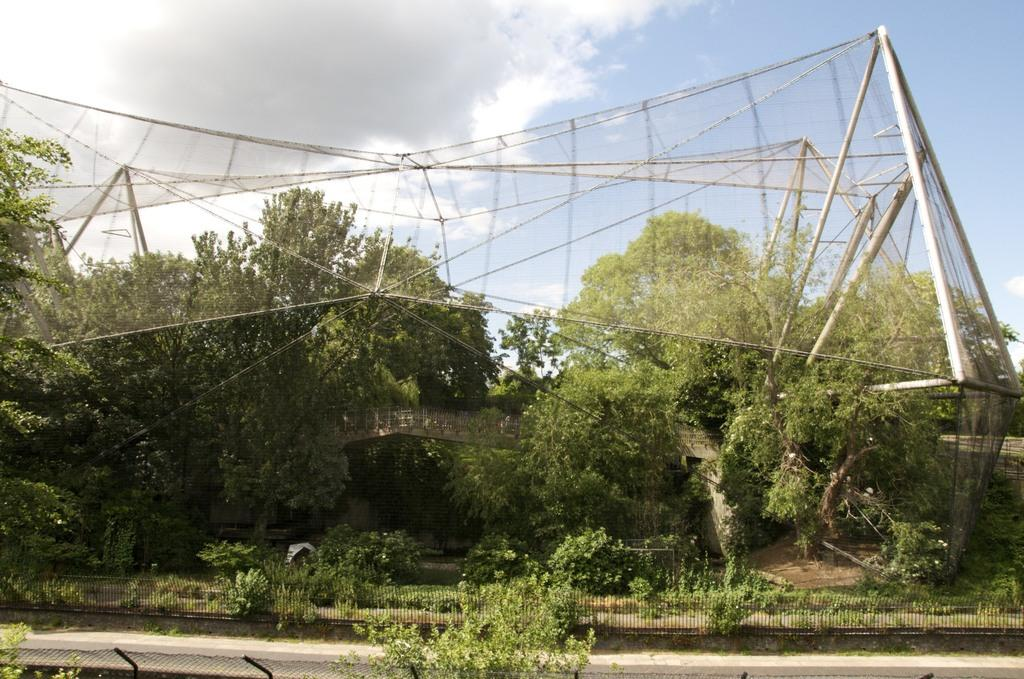What type of pathway is visible in the image? There is a road in the image. What structures can be seen alongside the road? F: There are fences in the image. What type of vegetation is present in the image? There are plants and trees in the image. What material is used to create a barrier in the image? There is a mesh in the image. What else can be seen in the image besides the road, fences, plants, and trees? There are objects in the image. What is visible in the background of the image? The sky is visible in the background of the image, with clouds present. What type of education is being offered to the banana in the image? There is no banana present in the image, so no education can be offered to it. How many passengers are visible in the image? There is no reference to passengers in the image, so it is not possible to determine their number. 